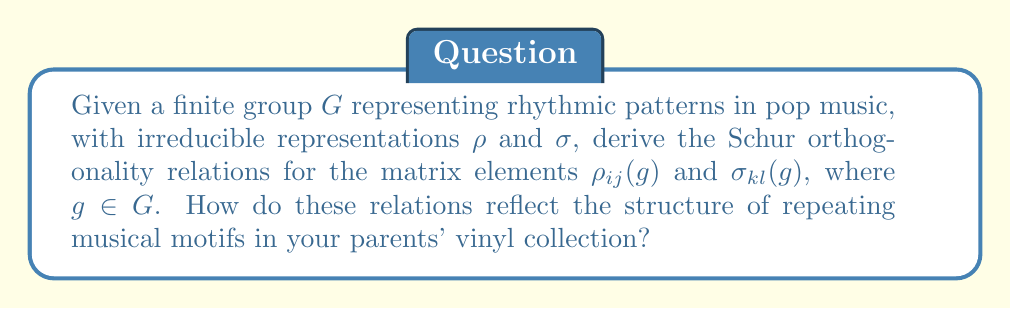Give your solution to this math problem. To derive the Schur orthogonality relations for the given scenario:

1) First, recall the general form of Schur orthogonality relations:

   $$\frac{1}{|G|} \sum_{g \in G} \rho_{ij}(g) \sigma_{kl}(g^{-1}) = \frac{1}{d_\rho} \delta_{\rho\sigma} \delta_{ik} \delta_{jl}$$

   where $d_\rho$ is the dimension of representation $\rho$.

2) In the context of rhythmic patterns:
   - $G$ represents the group of rhythmic transformations
   - $\rho_{ij}(g)$ and $\sigma_{kl}(g)$ represent how these transformations affect different aspects of the rhythm

3) The left side of the equation, $\frac{1}{|G|} \sum_{g \in G} \rho_{ij}(g) \sigma_{kl}(g^{-1})$, can be interpreted as averaging over all possible rhythmic transformations.

4) The right side, $\frac{1}{d_\rho} \delta_{\rho\sigma} \delta_{ik} \delta_{jl}$, implies:
   - Different irreducible representations (i.e., fundamentally different rhythm types) are orthogonal ($\delta_{\rho\sigma}$)
   - Within the same representation, only corresponding elements are correlated ($\delta_{ik} \delta_{jl}$)

5) This orthogonality reflects the structure of repeating musical motifs by:
   - Separating distinct rhythmic patterns (different representations are orthogonal)
   - Highlighting the internal consistency of each pattern (correlation within a representation)

6) The factor $\frac{1}{d_\rho}$ indicates that more complex rhythmic patterns (higher dimensional representations) have smaller individual correlations, reflecting the subtlety of intricate rhythms in sophisticated musical pieces.

This mathematical framework provides a formal way to analyze the rhythmic structures that might have inspired your early music, drawing from the diverse patterns in your parents' record collection.
Answer: $$\frac{1}{|G|} \sum_{g \in G} \rho_{ij}(g) \sigma_{kl}(g^{-1}) = \frac{1}{d_\rho} \delta_{\rho\sigma} \delta_{ik} \delta_{jl}$$ 